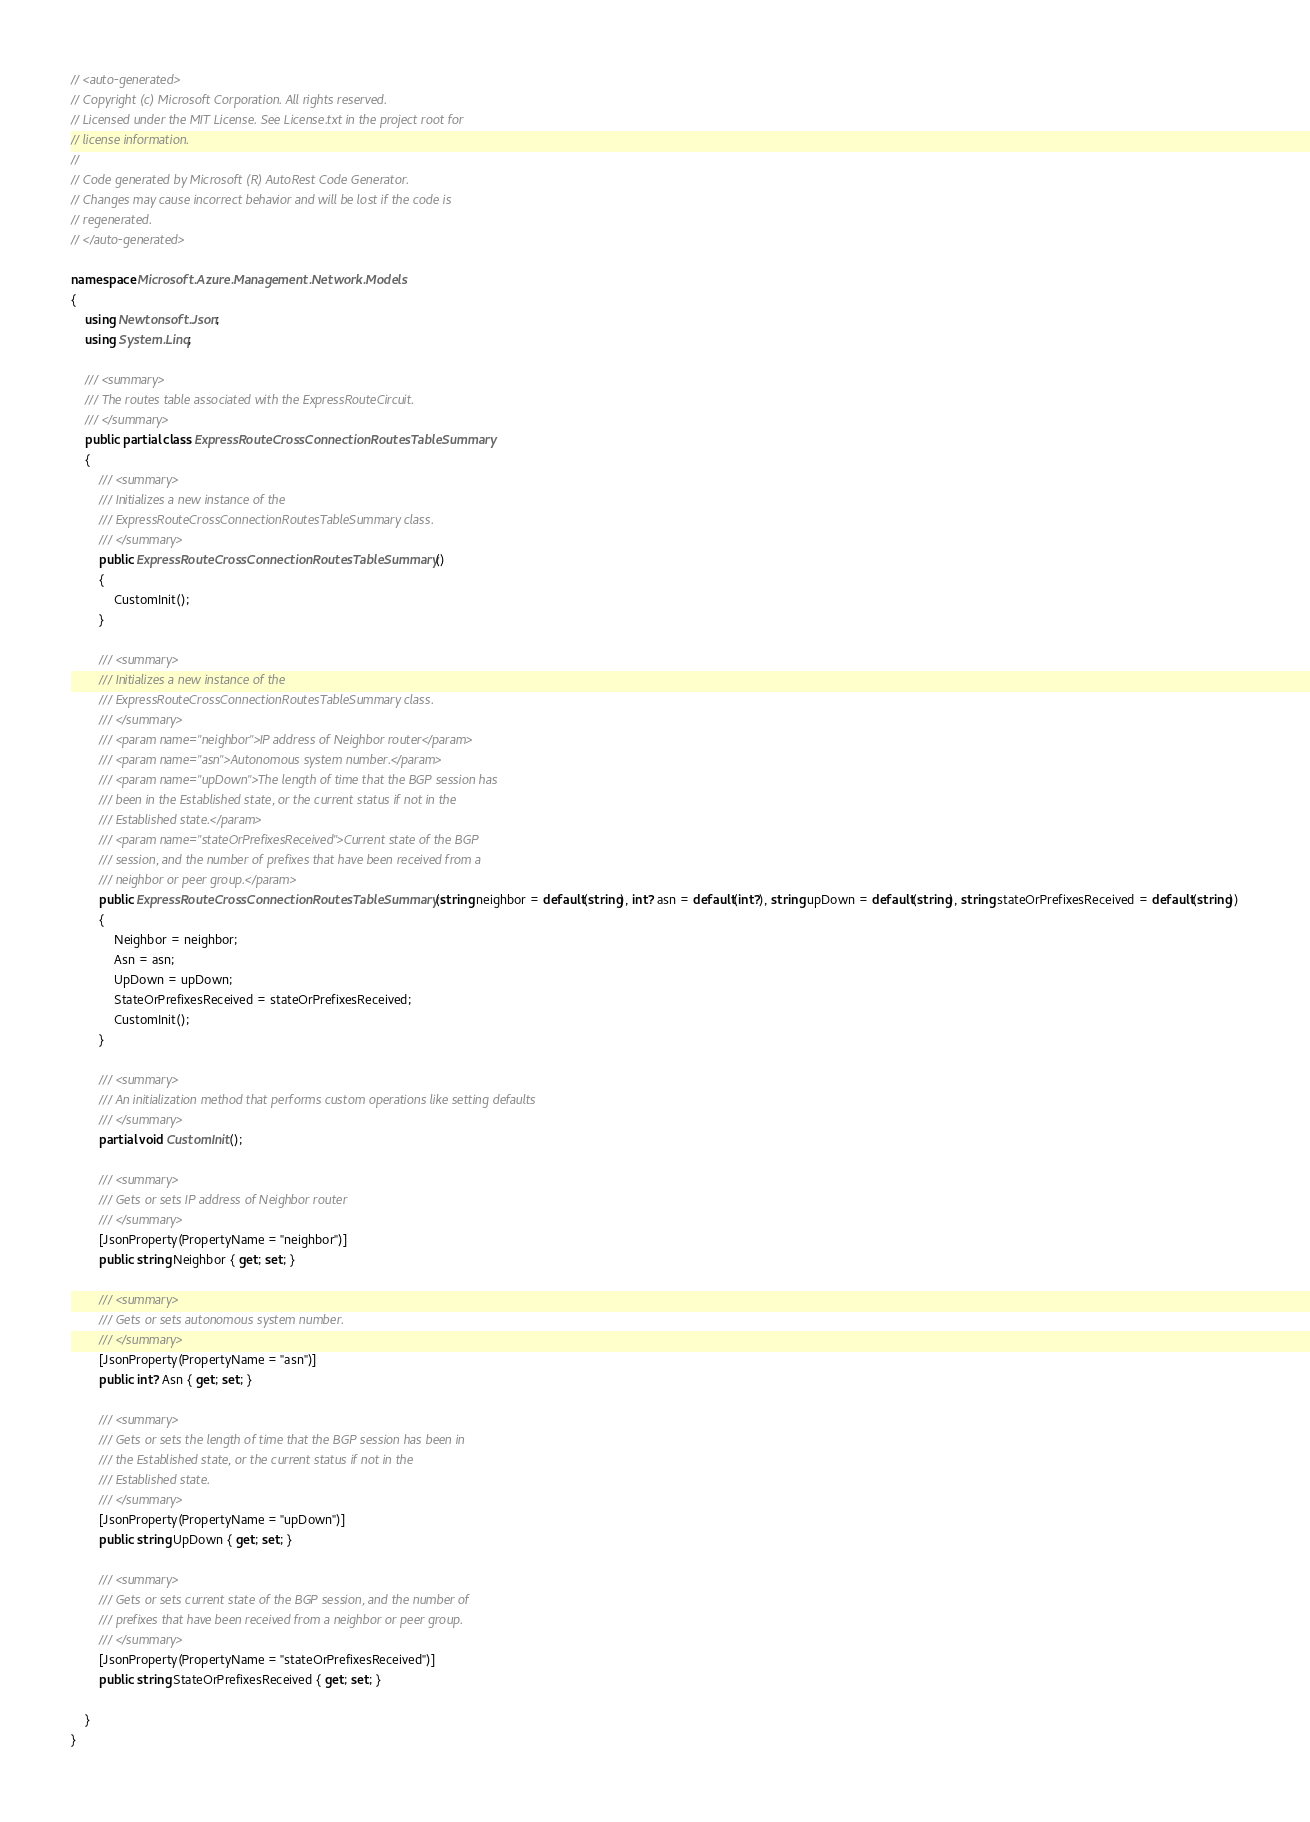Convert code to text. <code><loc_0><loc_0><loc_500><loc_500><_C#_>// <auto-generated>
// Copyright (c) Microsoft Corporation. All rights reserved.
// Licensed under the MIT License. See License.txt in the project root for
// license information.
//
// Code generated by Microsoft (R) AutoRest Code Generator.
// Changes may cause incorrect behavior and will be lost if the code is
// regenerated.
// </auto-generated>

namespace Microsoft.Azure.Management.Network.Models
{
    using Newtonsoft.Json;
    using System.Linq;

    /// <summary>
    /// The routes table associated with the ExpressRouteCircuit.
    /// </summary>
    public partial class ExpressRouteCrossConnectionRoutesTableSummary
    {
        /// <summary>
        /// Initializes a new instance of the
        /// ExpressRouteCrossConnectionRoutesTableSummary class.
        /// </summary>
        public ExpressRouteCrossConnectionRoutesTableSummary()
        {
            CustomInit();
        }

        /// <summary>
        /// Initializes a new instance of the
        /// ExpressRouteCrossConnectionRoutesTableSummary class.
        /// </summary>
        /// <param name="neighbor">IP address of Neighbor router</param>
        /// <param name="asn">Autonomous system number.</param>
        /// <param name="upDown">The length of time that the BGP session has
        /// been in the Established state, or the current status if not in the
        /// Established state.</param>
        /// <param name="stateOrPrefixesReceived">Current state of the BGP
        /// session, and the number of prefixes that have been received from a
        /// neighbor or peer group.</param>
        public ExpressRouteCrossConnectionRoutesTableSummary(string neighbor = default(string), int? asn = default(int?), string upDown = default(string), string stateOrPrefixesReceived = default(string))
        {
            Neighbor = neighbor;
            Asn = asn;
            UpDown = upDown;
            StateOrPrefixesReceived = stateOrPrefixesReceived;
            CustomInit();
        }

        /// <summary>
        /// An initialization method that performs custom operations like setting defaults
        /// </summary>
        partial void CustomInit();

        /// <summary>
        /// Gets or sets IP address of Neighbor router
        /// </summary>
        [JsonProperty(PropertyName = "neighbor")]
        public string Neighbor { get; set; }

        /// <summary>
        /// Gets or sets autonomous system number.
        /// </summary>
        [JsonProperty(PropertyName = "asn")]
        public int? Asn { get; set; }

        /// <summary>
        /// Gets or sets the length of time that the BGP session has been in
        /// the Established state, or the current status if not in the
        /// Established state.
        /// </summary>
        [JsonProperty(PropertyName = "upDown")]
        public string UpDown { get; set; }

        /// <summary>
        /// Gets or sets current state of the BGP session, and the number of
        /// prefixes that have been received from a neighbor or peer group.
        /// </summary>
        [JsonProperty(PropertyName = "stateOrPrefixesReceived")]
        public string StateOrPrefixesReceived { get; set; }

    }
}
</code> 